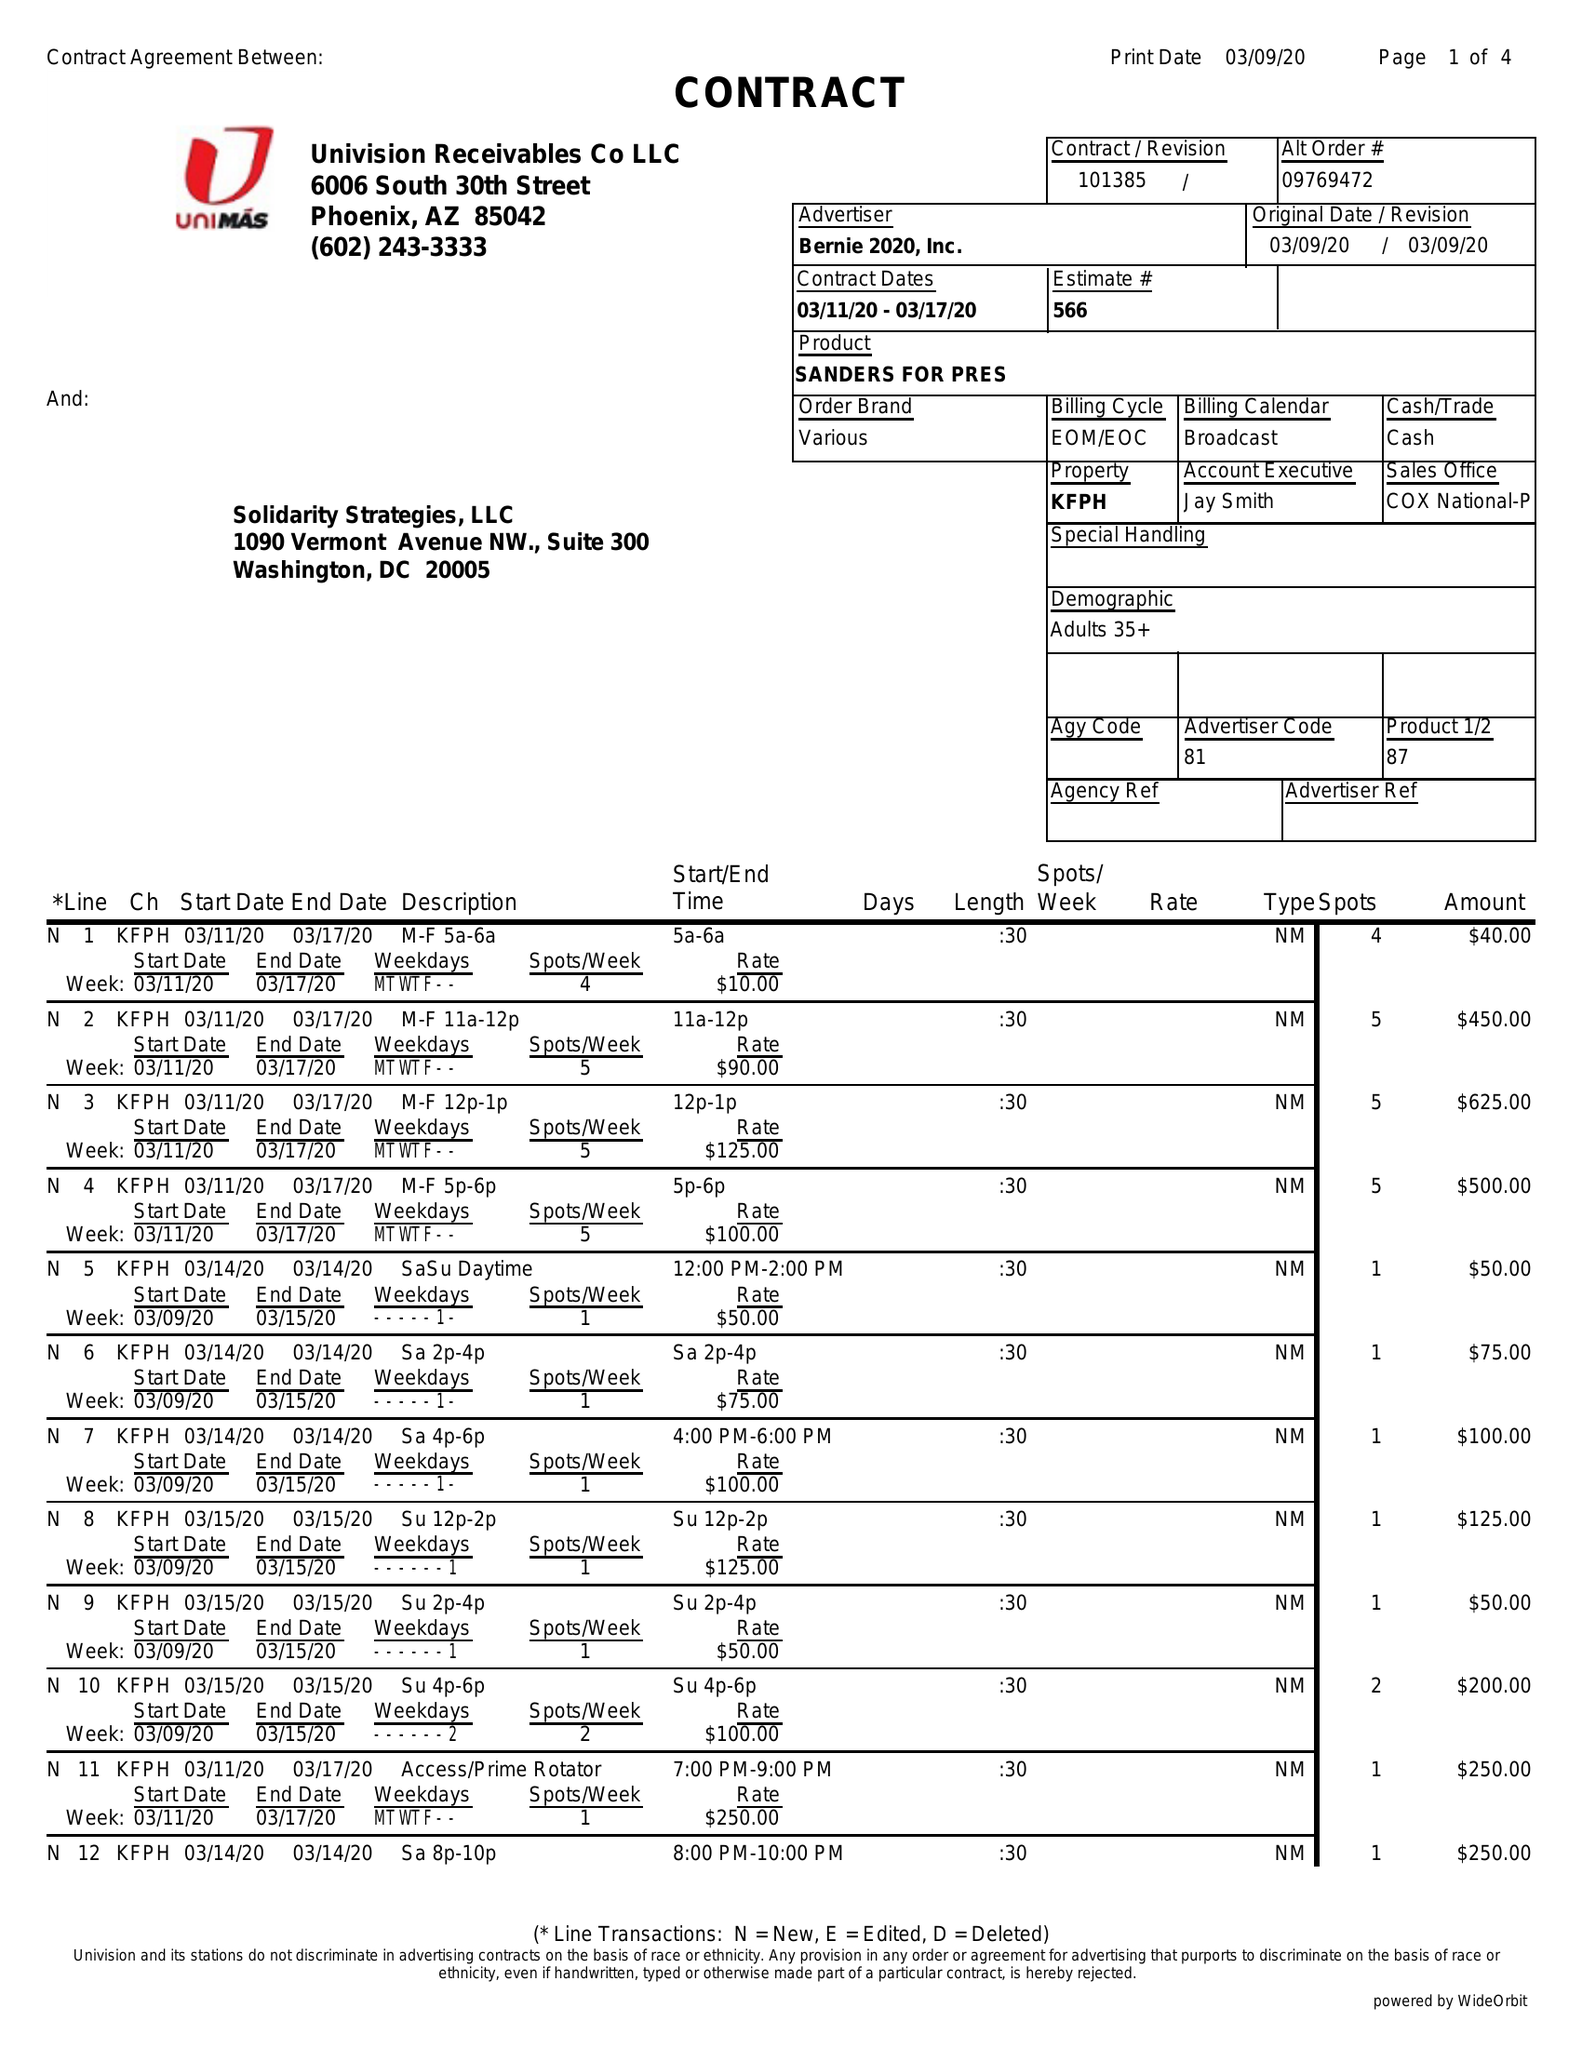What is the value for the flight_from?
Answer the question using a single word or phrase. 03/11/20 